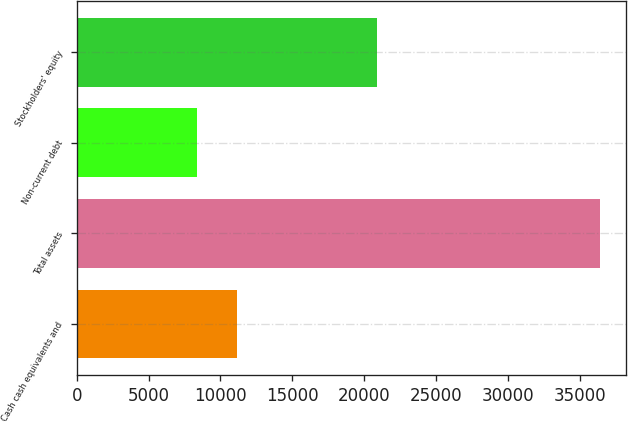Convert chart to OTSL. <chart><loc_0><loc_0><loc_500><loc_500><bar_chart><fcel>Cash cash equivalents and<fcel>Total assets<fcel>Non-current debt<fcel>Stockholders' equity<nl><fcel>11159.5<fcel>36427<fcel>8352<fcel>20885<nl></chart> 